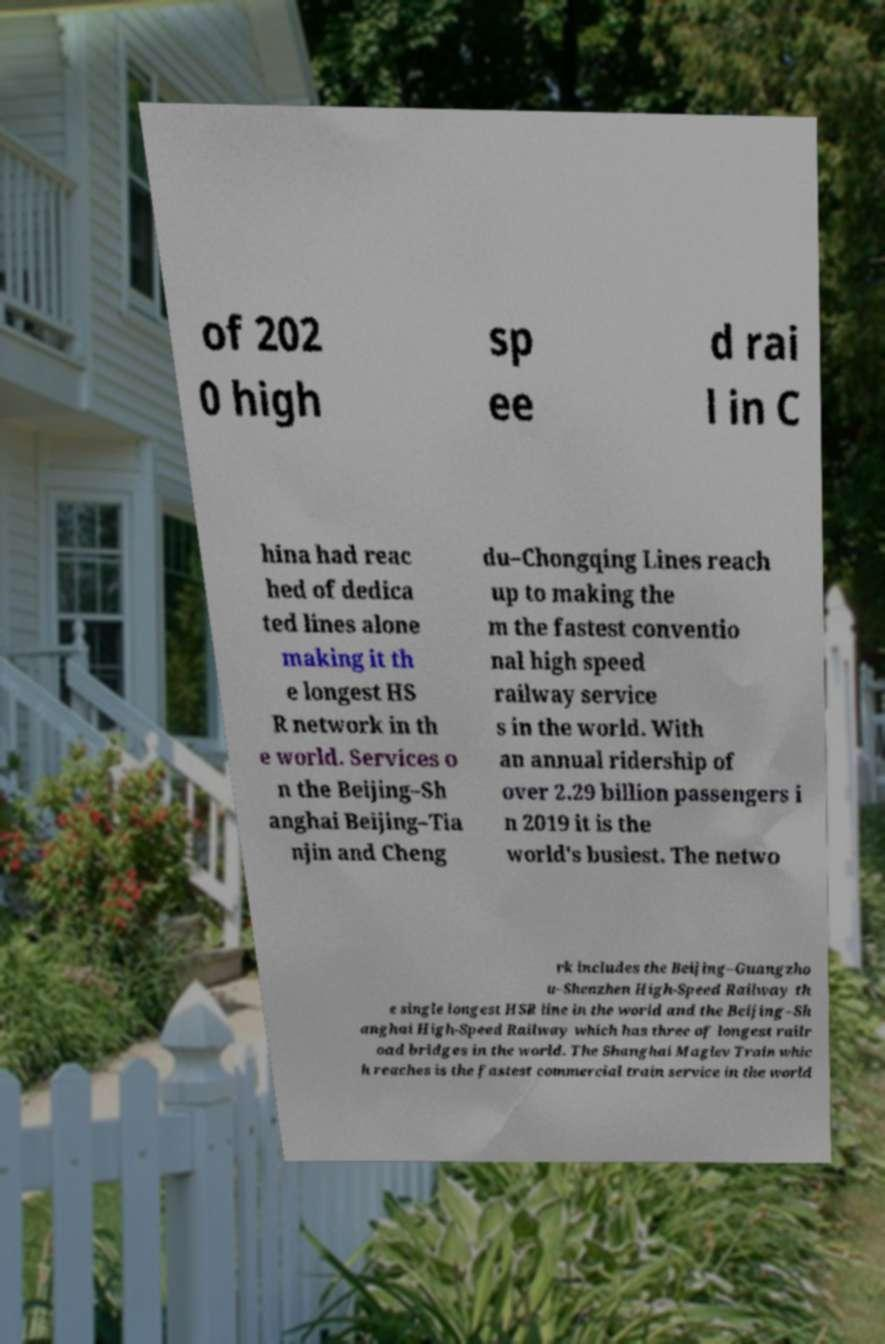For documentation purposes, I need the text within this image transcribed. Could you provide that? of 202 0 high sp ee d rai l in C hina had reac hed of dedica ted lines alone making it th e longest HS R network in th e world. Services o n the Beijing–Sh anghai Beijing–Tia njin and Cheng du–Chongqing Lines reach up to making the m the fastest conventio nal high speed railway service s in the world. With an annual ridership of over 2.29 billion passengers i n 2019 it is the world's busiest. The netwo rk includes the Beijing–Guangzho u–Shenzhen High-Speed Railway th e single longest HSR line in the world and the Beijing–Sh anghai High-Speed Railway which has three of longest railr oad bridges in the world. The Shanghai Maglev Train whic h reaches is the fastest commercial train service in the world 